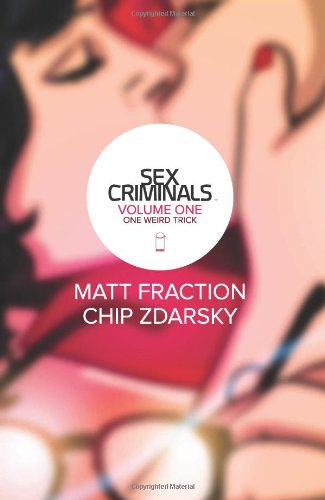Is this a comics book? Yes, it is a comics book, specifically a graphic novel with a compelling narrative and rich artwork designed to engage adult readers. 